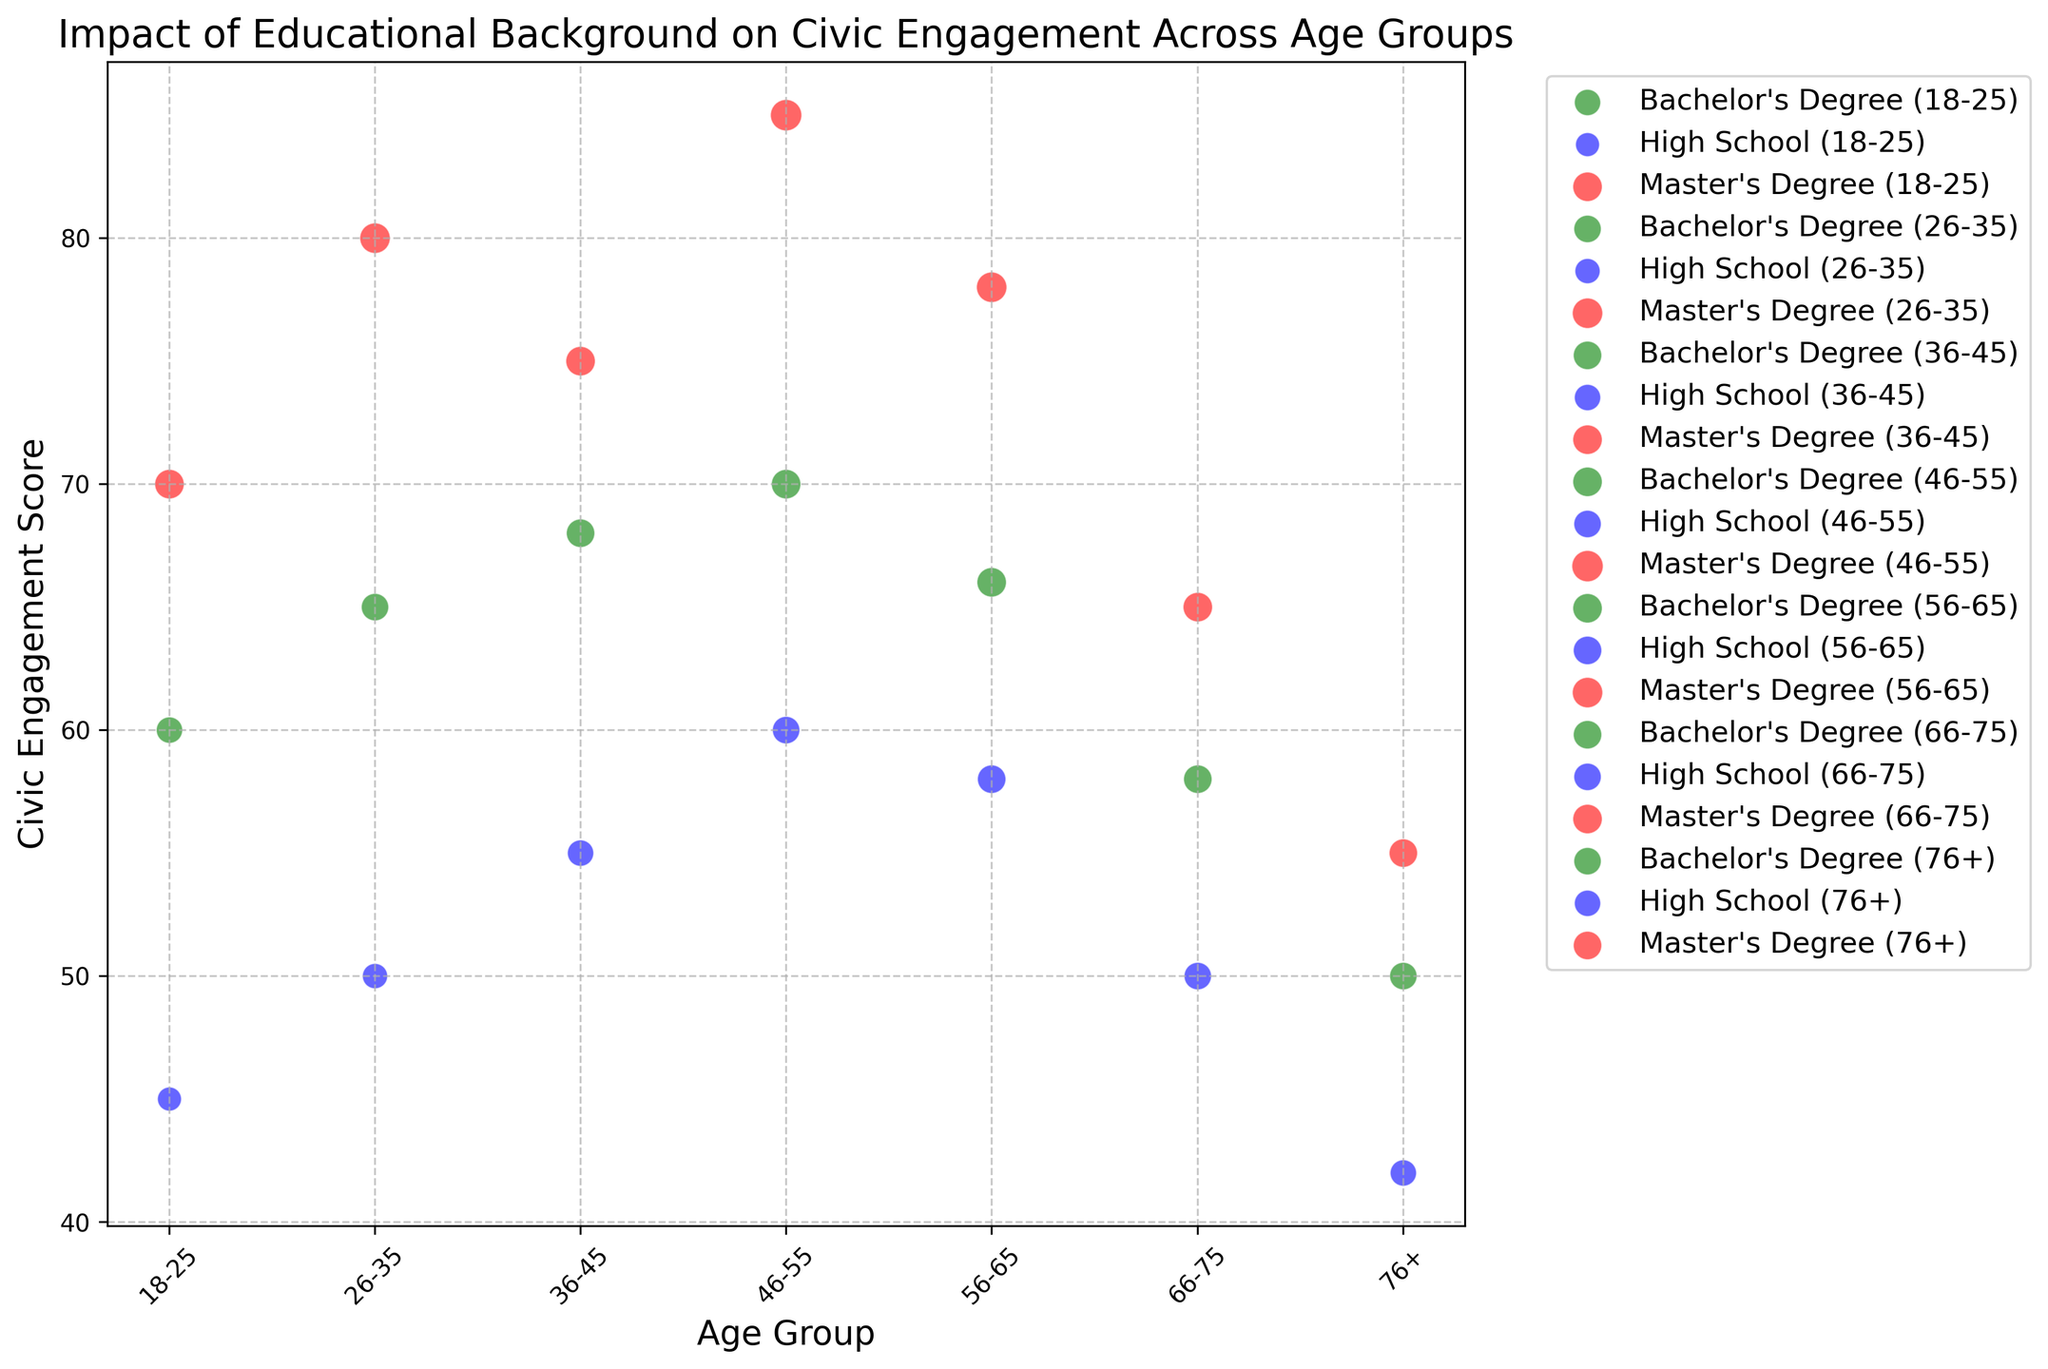Which age group with a Master's Degree has the highest Civic Engagement Score? First, identify the bubbles associated with Master's Degree, which are in red. Then, look for the red bubble with the highest vertical position (Civic Engagement Score). This is the 46-55 age group with a score of 85.
Answer: 46-55 Which educational background shows the highest Civic Engagement Score in age group 18-25? Focus on the 18-25 age group and compare the Civic Engagement Scores for High School (blue), Bachelor's Degree (green), and Master's Degree (red). The Master's Degree bubble is the highest with a score of 70.
Answer: Master's Degree Compare the Civic Engagement Scores of the 56-65 age group with a Bachelor's Degree and the 66-75 age group with a Master's Degree. Which one is higher? Look at the Civic Engagement Scores for these age and educational groups. The Bachelor's Degree score for 56-65 is 66, and the Master's Degree score for 66-75 is 65. Thus, the 56-65 Bachelor's Degree score is higher.
Answer: 56-65 Bachelor's Degree Considering all the age groups, which educational background generally has the largest bubble sizes? Observe the bubble sizes for High School (blue), Bachelor's Degree (green), and Master's Degree (red). The red bubbles (Master's Degree) generally appear larger across the age groups.
Answer: Master's Degree What is the difference in Civic Engagement Score between the 26-35 and 36-45 age groups with a Bachelor's Degree? Compare the Civic Engagement Scores for the Bachelor's Degree in these age groups. The score for 26-35 is 65, and for 36-45 it's 68. The difference is 68 - 65 = 3.
Answer: 3 Which age group with a High School education has the lowest Civic Engagement Score? Look for the blue bubbles, which represent High School education, and identify the one with the lowest vertical position. The 76+ age group has the lowest score at 42.
Answer: 76+ How does the Civic Engagement Score for the 46-55 age group with a Bachelor's Degree compare to the 66-75 age group with a Bachelor's Degree? Identify the green bubbles for the 46-55 (score 70) and 66-75 (score 58) age groups. The 46-55 group has a higher Civic Engagement Score.
Answer: 46-55 If you sum the Civic Engagement Scores for the 18-25 age group across all educational backgrounds, what is the total? Add the scores for High School (45), Bachelor's Degree (60), and Master's Degree (70). The sum is 45 + 60 + 70 = 175.
Answer: 175 How do the Civic Engagement Scores compare between the 36-45 age group with a Master's Degree and the 56-65 age group with a Master's Degree? Compare the Civic Engagement Scores for Master's Degree in these age groups. The score for 36-45 is 75, and for 56-65 it's 78. The 56-65 age group has a higher score.
Answer: 56-65 Which educational background in the 76+ age group has a bubble size of 14? Determine the bubble sizes for the 76+ age group to find the corresponding educational background. The red bubble represents a Master's Degree, which has the size of 14.
Answer: Master's Degree 